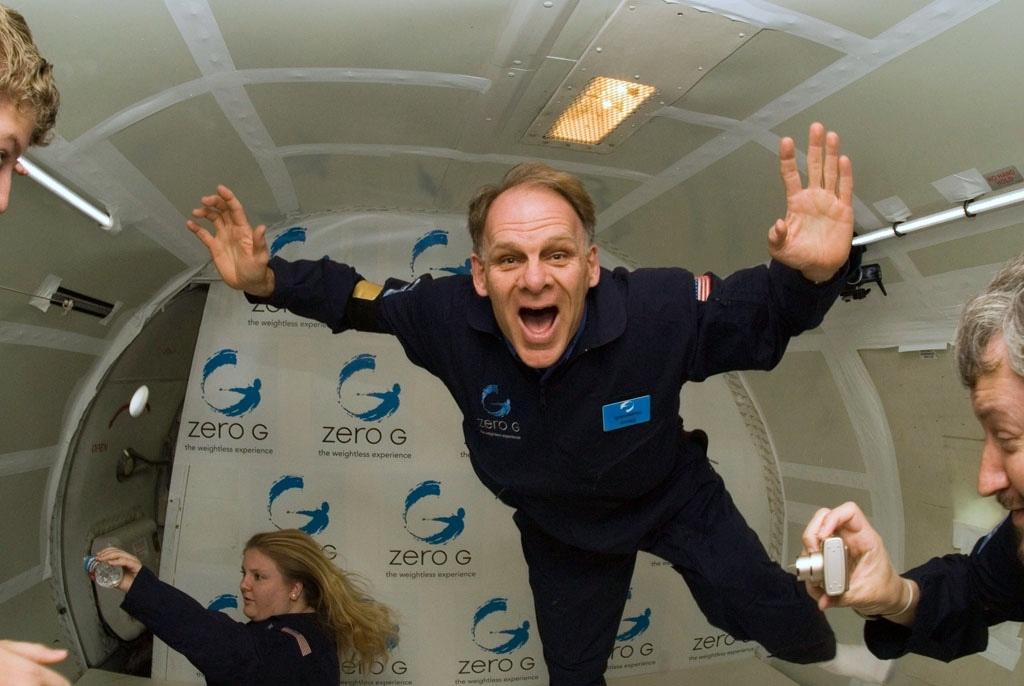Please provide a concise description of this image. There are people and this man holding a camera and she is holding a bottle. We can see lights and rod. In the background we can see banner. 